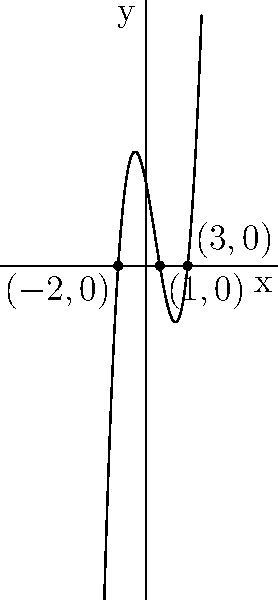Given the polynomial function $f(x) = (x+2)(x-1)(x-3)$, sketch its graph. What are the x-intercepts, and what is the end behavior of the function as $x$ approaches positive and negative infinity? To sketch the graph of the polynomial $f(x) = (x+2)(x-1)(x-3)$, we follow these steps:

1) Identify the roots (x-intercepts):
   Set $f(x) = 0$ and solve:
   $(x+2)(x-1)(x-3) = 0$
   $x = -2$, or $x = 1$, or $x = 3$

2) Determine the y-intercept:
   Evaluate $f(0) = (0+2)(0-1)(0-3) = 2(-1)(-3) = 6$

3) Analyze the end behavior:
   The degree of the polynomial is 3 (odd), and the leading coefficient is positive.
   As $x \to +\infty$, $f(x) \to +\infty$
   As $x \to -\infty$, $f(x) \to -\infty$

4) Determine the behavior near the roots:
   - At $x = -2$: the graph crosses the x-axis from below
   - At $x = 1$: the graph crosses the x-axis from below
   - At $x = 3$: the graph crosses the x-axis from below

5) Sketch the graph:
   - Plot the x-intercepts: $(-2,0)$, $(1,0)$, and $(3,0)$
   - Plot the y-intercept: $(0,6)$
   - Draw a smooth curve that passes through these points, respecting the end behavior and behavior near the roots

The resulting graph is a cubic function that starts in the third quadrant, crosses the x-axis at $x = -2$, rises to cross the y-axis at $(0,6)$, dips down to cross the x-axis again at $x = 1$, then rises once more to cross at $x = 3$, and continues upward into the first quadrant.
Answer: X-intercepts: $(-2,0)$, $(1,0)$, $(3,0)$. End behavior: $f(x) \to +\infty$ as $x \to +\infty$, $f(x) \to -\infty$ as $x \to -\infty$. 